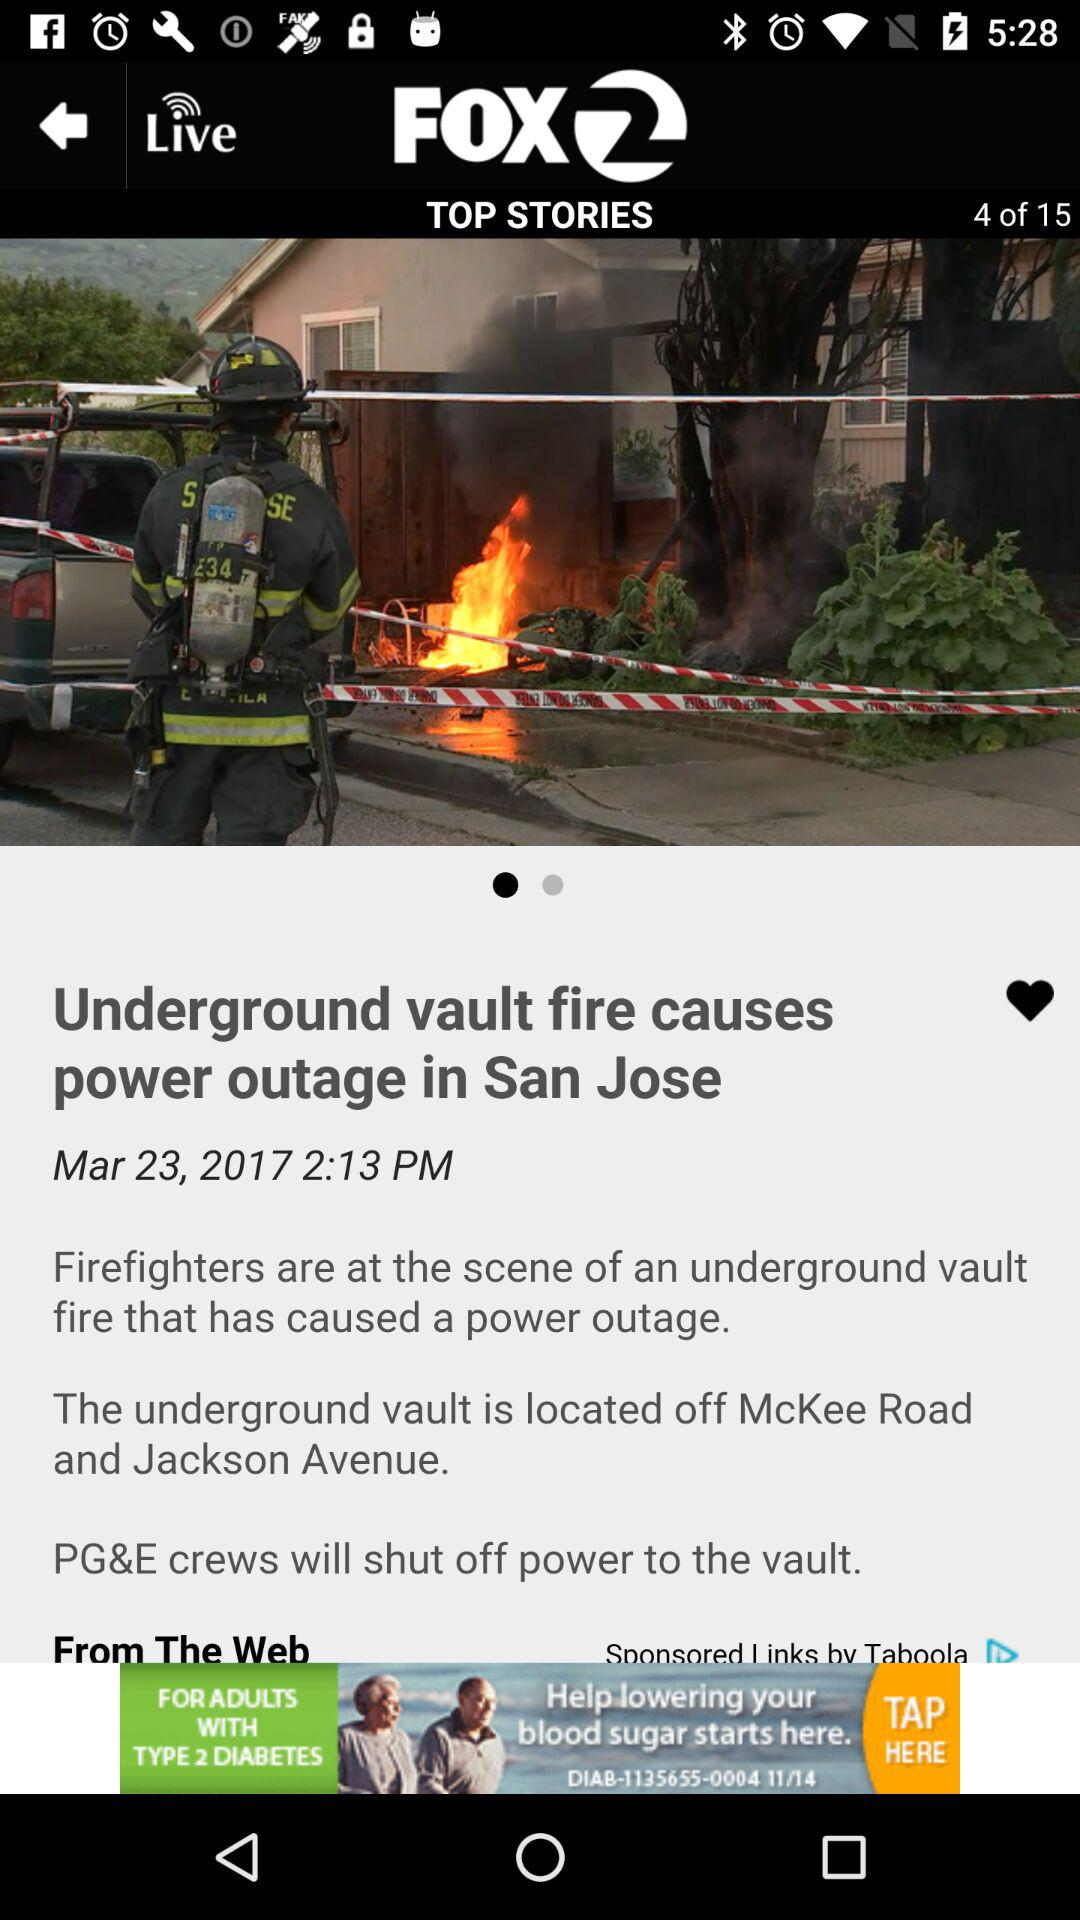What is the title of the article? The title of the article is "Underground vault fire causes power outage in San Jose". 